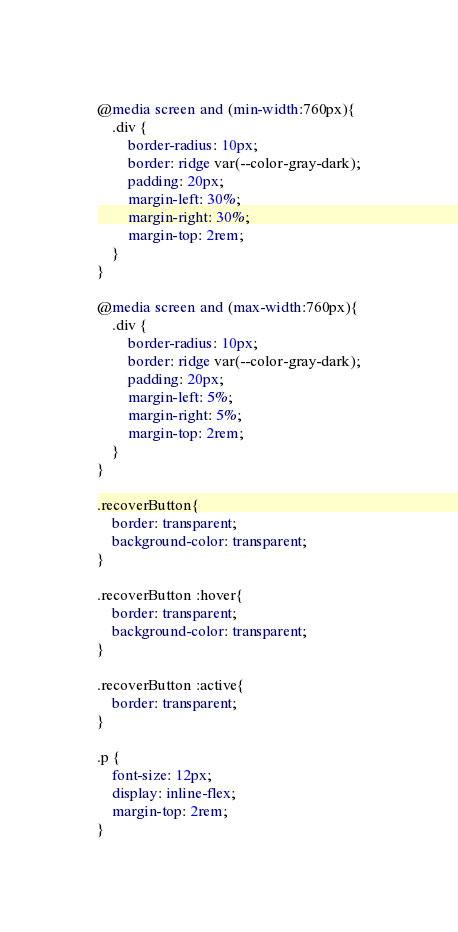Convert code to text. <code><loc_0><loc_0><loc_500><loc_500><_CSS_>
@media screen and (min-width:760px){
    .div {
        border-radius: 10px;
        border: ridge var(--color-gray-dark);
        padding: 20px;
        margin-left: 30%;
        margin-right: 30%;
        margin-top: 2rem;
    }
}

@media screen and (max-width:760px){
    .div {
        border-radius: 10px;
        border: ridge var(--color-gray-dark);
        padding: 20px;
        margin-left: 5%;
        margin-right: 5%;
        margin-top: 2rem;
    }
}

.recoverButton{
    border: transparent;
    background-color: transparent;
}

.recoverButton :hover{
    border: transparent;
    background-color: transparent;
}

.recoverButton :active{
    border: transparent;
}

.p {
    font-size: 12px;
    display: inline-flex;
    margin-top: 2rem;
}</code> 